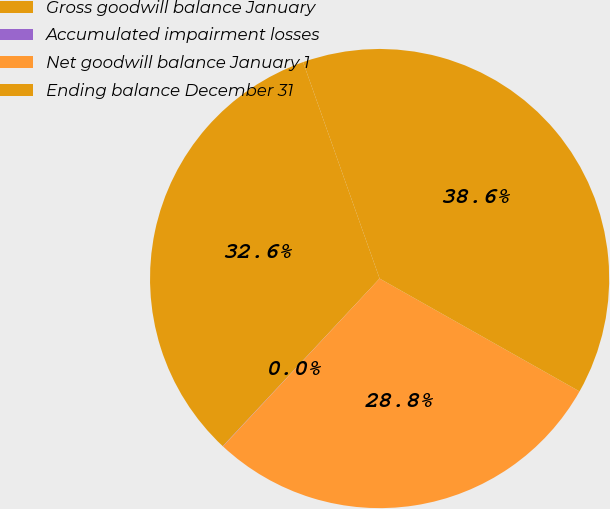<chart> <loc_0><loc_0><loc_500><loc_500><pie_chart><fcel>Gross goodwill balance January<fcel>Accumulated impairment losses<fcel>Net goodwill balance January 1<fcel>Ending balance December 31<nl><fcel>32.62%<fcel>0.02%<fcel>28.77%<fcel>38.59%<nl></chart> 